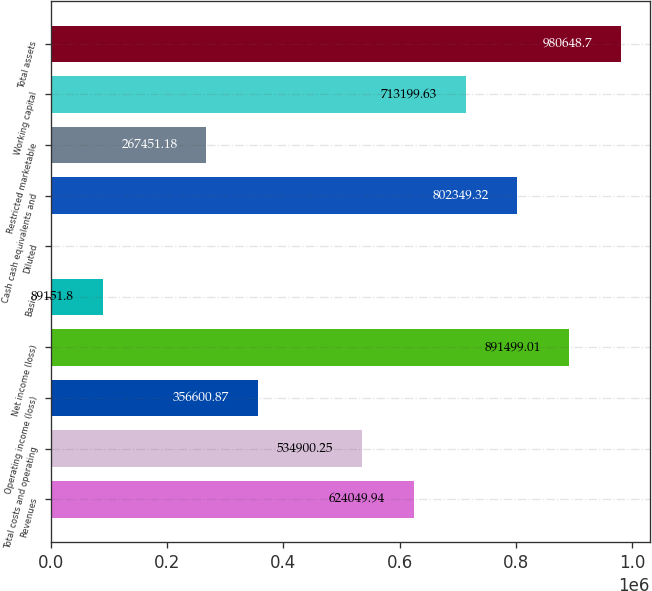Convert chart to OTSL. <chart><loc_0><loc_0><loc_500><loc_500><bar_chart><fcel>Revenues<fcel>Total costs and operating<fcel>Operating income (loss)<fcel>Net income (loss)<fcel>Basic<fcel>Diluted<fcel>Cash cash equivalents and<fcel>Restricted marketable<fcel>Working capital<fcel>Total assets<nl><fcel>624050<fcel>534900<fcel>356601<fcel>891499<fcel>89151.8<fcel>2.11<fcel>802349<fcel>267451<fcel>713200<fcel>980649<nl></chart> 